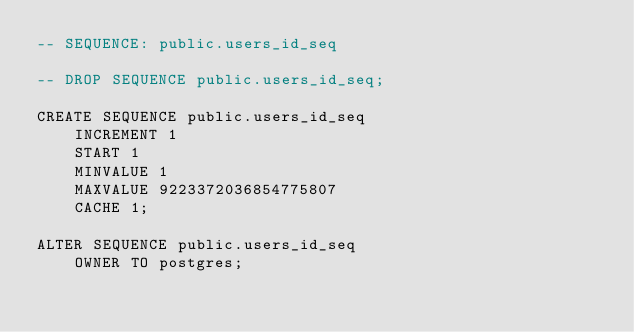<code> <loc_0><loc_0><loc_500><loc_500><_SQL_>-- SEQUENCE: public.users_id_seq

-- DROP SEQUENCE public.users_id_seq;

CREATE SEQUENCE public.users_id_seq
    INCREMENT 1
    START 1
    MINVALUE 1
    MAXVALUE 9223372036854775807
    CACHE 1;

ALTER SEQUENCE public.users_id_seq
    OWNER TO postgres;</code> 